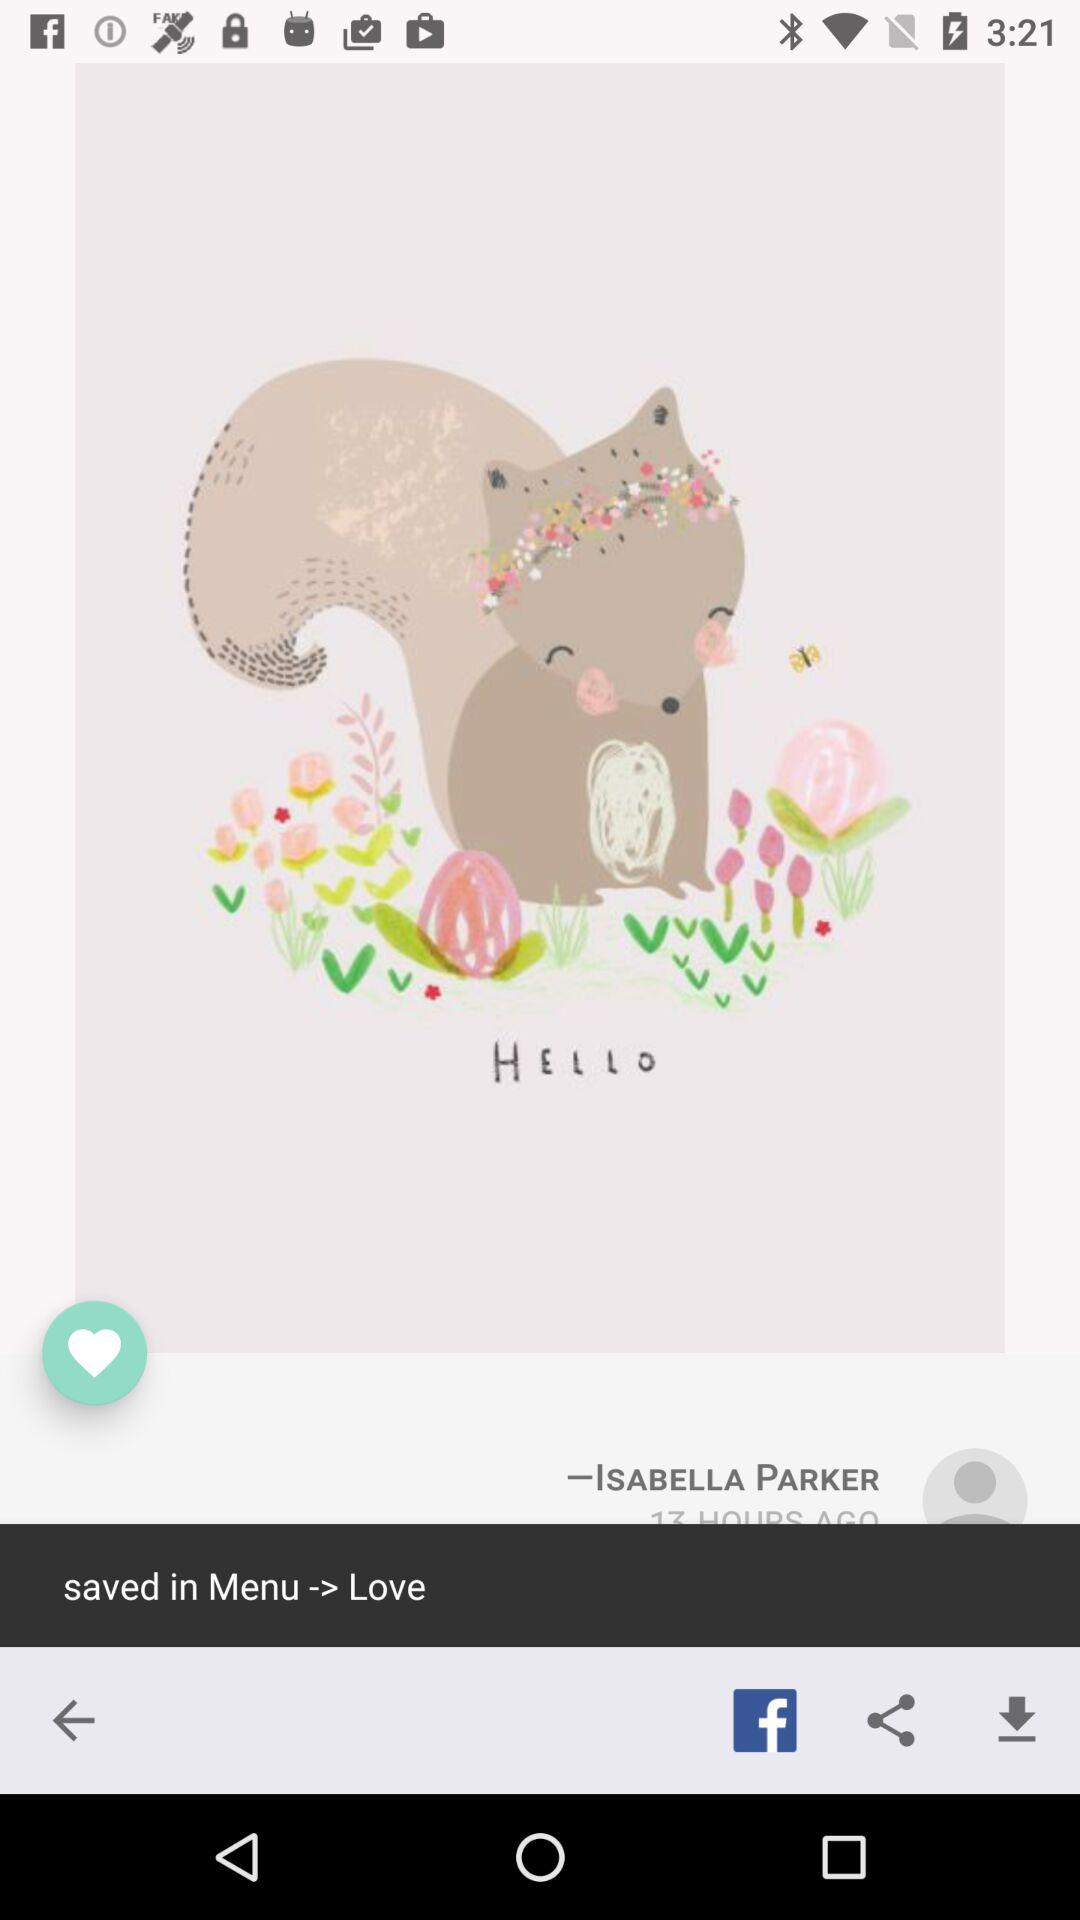What is the name? The name is Isabella Parker. 